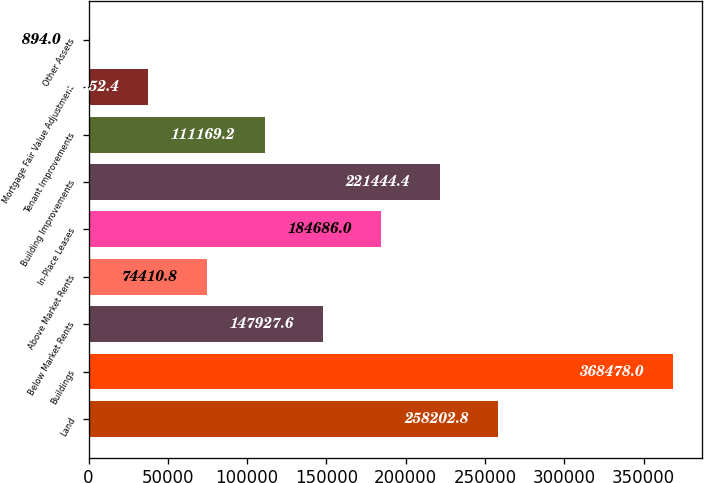Convert chart. <chart><loc_0><loc_0><loc_500><loc_500><bar_chart><fcel>Land<fcel>Buildings<fcel>Below Market Rents<fcel>Above Market Rents<fcel>In-Place Leases<fcel>Building Improvements<fcel>Tenant Improvements<fcel>Mortgage Fair Value Adjustment<fcel>Other Assets<nl><fcel>258203<fcel>368478<fcel>147928<fcel>74410.8<fcel>184686<fcel>221444<fcel>111169<fcel>37652.4<fcel>894<nl></chart> 